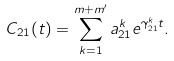Convert formula to latex. <formula><loc_0><loc_0><loc_500><loc_500>C _ { 2 1 } ( t ) = \sum _ { k = 1 } ^ { m + m ^ { \prime } } a _ { 2 1 } ^ { k } e ^ { \gamma _ { 2 1 } ^ { k } t } .</formula> 